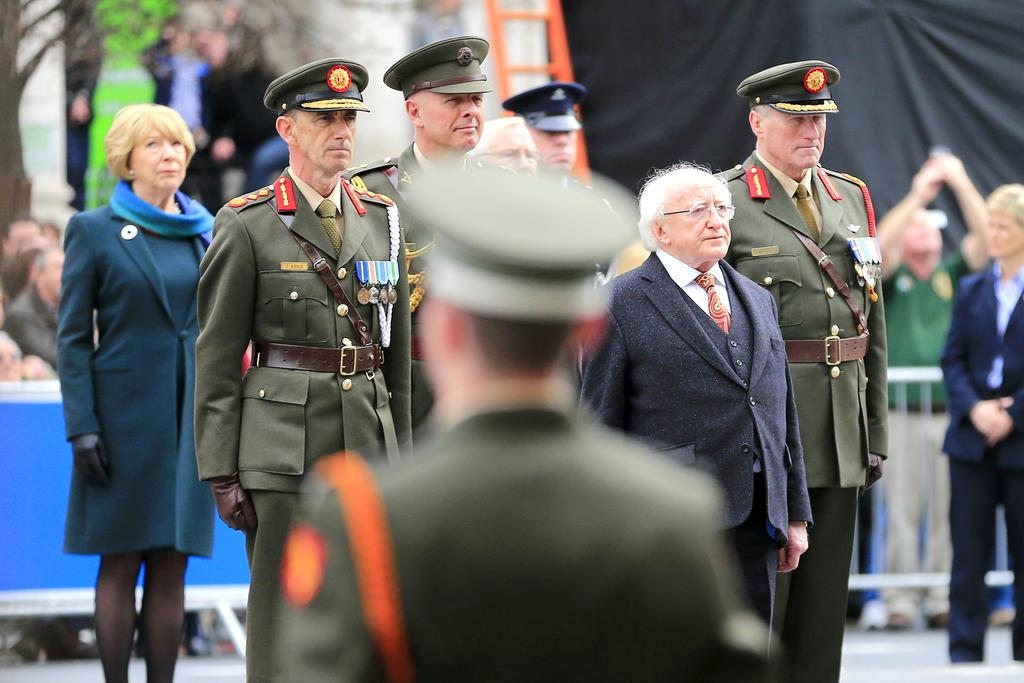What are the people in the image doing? The people in the image are standing in the center. What can be seen in the image besides the people? There is a fence in the image. What is visible in the background of the image? There is a tree and a curtain in the background of the image. Can you show me the receipt for the lawyer's services in the image? There is no receipt or lawyer present in the image. 